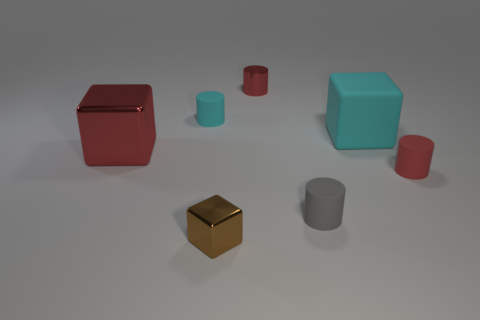Subtract all red metallic cubes. How many cubes are left? 2 Subtract all cyan cylinders. How many cylinders are left? 3 Subtract 2 cylinders. How many cylinders are left? 2 Add 3 tiny gray cylinders. How many objects exist? 10 Subtract all blocks. How many objects are left? 4 Subtract all cyan cubes. Subtract all gray cylinders. How many cubes are left? 2 Subtract all brown spheres. How many cyan cylinders are left? 1 Subtract all small green metal cubes. Subtract all big red blocks. How many objects are left? 6 Add 6 small red cylinders. How many small red cylinders are left? 8 Add 1 small red cylinders. How many small red cylinders exist? 3 